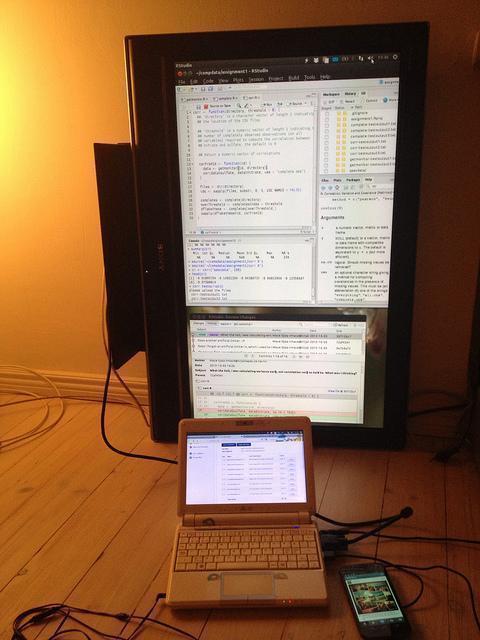What is sitting next to the laptop?
Choose the correct response, then elucidate: 'Answer: answer
Rationale: rationale.'
Options: Book, magazine, newspaper, cell phone. Answer: cell phone.
Rationale: The screen is on and it's small and flat 